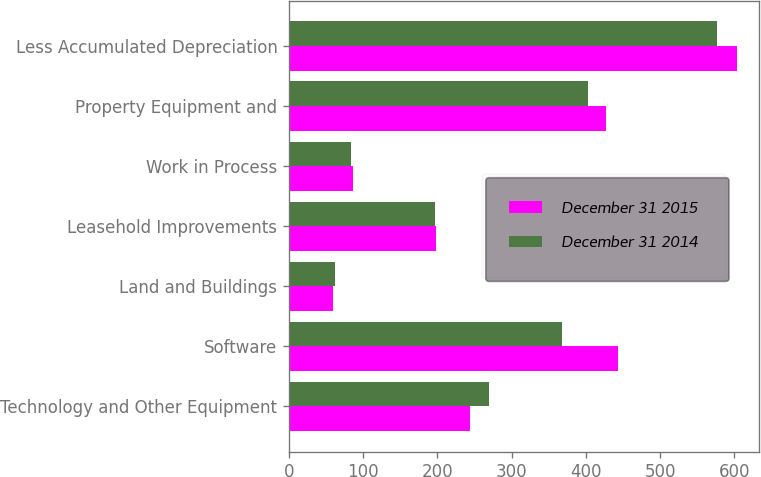Convert chart to OTSL. <chart><loc_0><loc_0><loc_500><loc_500><stacked_bar_chart><ecel><fcel>Technology and Other Equipment<fcel>Software<fcel>Land and Buildings<fcel>Leasehold Improvements<fcel>Work in Process<fcel>Property Equipment and<fcel>Less Accumulated Depreciation<nl><fcel>December 31 2015<fcel>244.1<fcel>443<fcel>58.9<fcel>198.2<fcel>85.8<fcel>426.9<fcel>603.1<nl><fcel>December 31 2014<fcel>268.9<fcel>368.3<fcel>62.3<fcel>196.1<fcel>84<fcel>402.6<fcel>577<nl></chart> 